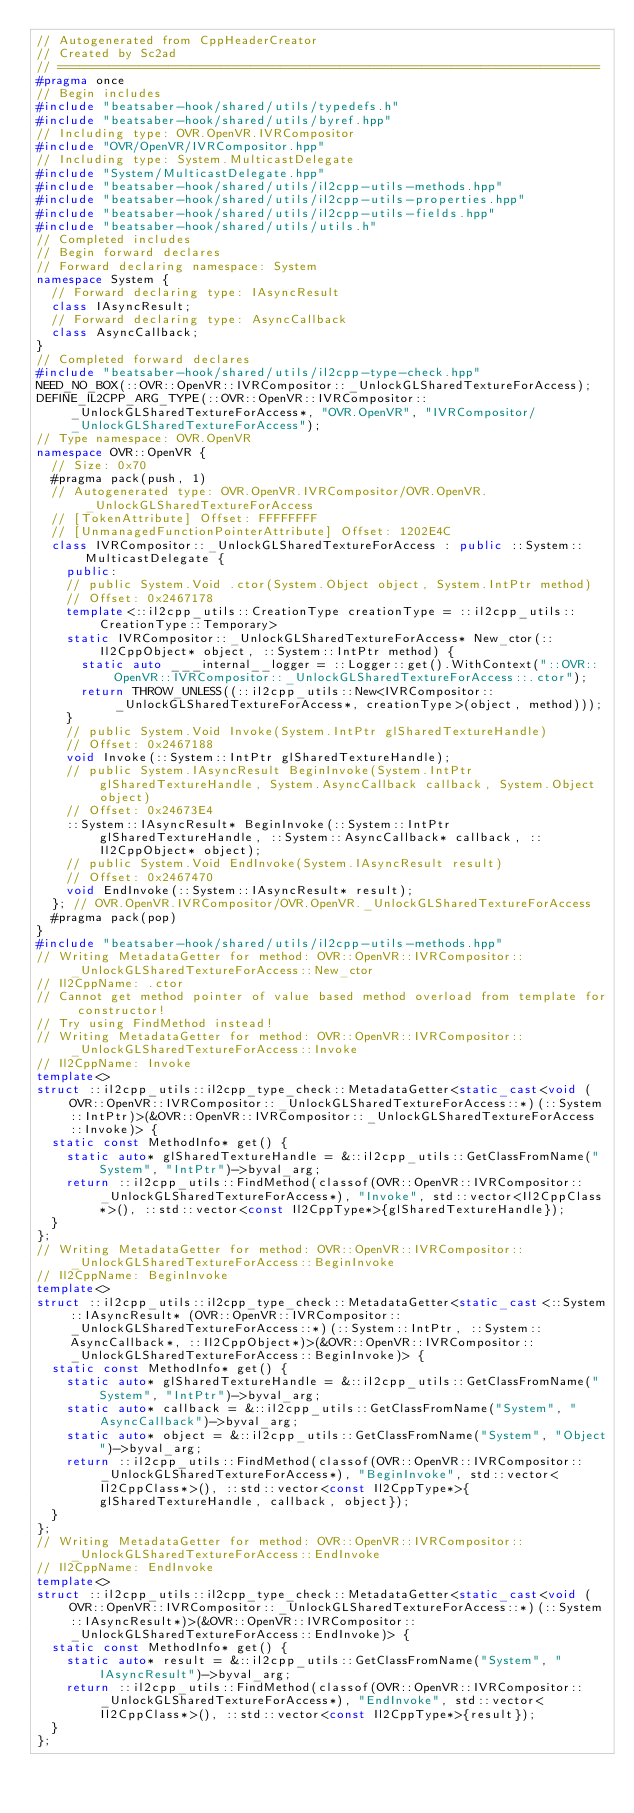<code> <loc_0><loc_0><loc_500><loc_500><_C++_>// Autogenerated from CppHeaderCreator
// Created by Sc2ad
// =========================================================================
#pragma once
// Begin includes
#include "beatsaber-hook/shared/utils/typedefs.h"
#include "beatsaber-hook/shared/utils/byref.hpp"
// Including type: OVR.OpenVR.IVRCompositor
#include "OVR/OpenVR/IVRCompositor.hpp"
// Including type: System.MulticastDelegate
#include "System/MulticastDelegate.hpp"
#include "beatsaber-hook/shared/utils/il2cpp-utils-methods.hpp"
#include "beatsaber-hook/shared/utils/il2cpp-utils-properties.hpp"
#include "beatsaber-hook/shared/utils/il2cpp-utils-fields.hpp"
#include "beatsaber-hook/shared/utils/utils.h"
// Completed includes
// Begin forward declares
// Forward declaring namespace: System
namespace System {
  // Forward declaring type: IAsyncResult
  class IAsyncResult;
  // Forward declaring type: AsyncCallback
  class AsyncCallback;
}
// Completed forward declares
#include "beatsaber-hook/shared/utils/il2cpp-type-check.hpp"
NEED_NO_BOX(::OVR::OpenVR::IVRCompositor::_UnlockGLSharedTextureForAccess);
DEFINE_IL2CPP_ARG_TYPE(::OVR::OpenVR::IVRCompositor::_UnlockGLSharedTextureForAccess*, "OVR.OpenVR", "IVRCompositor/_UnlockGLSharedTextureForAccess");
// Type namespace: OVR.OpenVR
namespace OVR::OpenVR {
  // Size: 0x70
  #pragma pack(push, 1)
  // Autogenerated type: OVR.OpenVR.IVRCompositor/OVR.OpenVR._UnlockGLSharedTextureForAccess
  // [TokenAttribute] Offset: FFFFFFFF
  // [UnmanagedFunctionPointerAttribute] Offset: 1202E4C
  class IVRCompositor::_UnlockGLSharedTextureForAccess : public ::System::MulticastDelegate {
    public:
    // public System.Void .ctor(System.Object object, System.IntPtr method)
    // Offset: 0x2467178
    template<::il2cpp_utils::CreationType creationType = ::il2cpp_utils::CreationType::Temporary>
    static IVRCompositor::_UnlockGLSharedTextureForAccess* New_ctor(::Il2CppObject* object, ::System::IntPtr method) {
      static auto ___internal__logger = ::Logger::get().WithContext("::OVR::OpenVR::IVRCompositor::_UnlockGLSharedTextureForAccess::.ctor");
      return THROW_UNLESS((::il2cpp_utils::New<IVRCompositor::_UnlockGLSharedTextureForAccess*, creationType>(object, method)));
    }
    // public System.Void Invoke(System.IntPtr glSharedTextureHandle)
    // Offset: 0x2467188
    void Invoke(::System::IntPtr glSharedTextureHandle);
    // public System.IAsyncResult BeginInvoke(System.IntPtr glSharedTextureHandle, System.AsyncCallback callback, System.Object object)
    // Offset: 0x24673E4
    ::System::IAsyncResult* BeginInvoke(::System::IntPtr glSharedTextureHandle, ::System::AsyncCallback* callback, ::Il2CppObject* object);
    // public System.Void EndInvoke(System.IAsyncResult result)
    // Offset: 0x2467470
    void EndInvoke(::System::IAsyncResult* result);
  }; // OVR.OpenVR.IVRCompositor/OVR.OpenVR._UnlockGLSharedTextureForAccess
  #pragma pack(pop)
}
#include "beatsaber-hook/shared/utils/il2cpp-utils-methods.hpp"
// Writing MetadataGetter for method: OVR::OpenVR::IVRCompositor::_UnlockGLSharedTextureForAccess::New_ctor
// Il2CppName: .ctor
// Cannot get method pointer of value based method overload from template for constructor!
// Try using FindMethod instead!
// Writing MetadataGetter for method: OVR::OpenVR::IVRCompositor::_UnlockGLSharedTextureForAccess::Invoke
// Il2CppName: Invoke
template<>
struct ::il2cpp_utils::il2cpp_type_check::MetadataGetter<static_cast<void (OVR::OpenVR::IVRCompositor::_UnlockGLSharedTextureForAccess::*)(::System::IntPtr)>(&OVR::OpenVR::IVRCompositor::_UnlockGLSharedTextureForAccess::Invoke)> {
  static const MethodInfo* get() {
    static auto* glSharedTextureHandle = &::il2cpp_utils::GetClassFromName("System", "IntPtr")->byval_arg;
    return ::il2cpp_utils::FindMethod(classof(OVR::OpenVR::IVRCompositor::_UnlockGLSharedTextureForAccess*), "Invoke", std::vector<Il2CppClass*>(), ::std::vector<const Il2CppType*>{glSharedTextureHandle});
  }
};
// Writing MetadataGetter for method: OVR::OpenVR::IVRCompositor::_UnlockGLSharedTextureForAccess::BeginInvoke
// Il2CppName: BeginInvoke
template<>
struct ::il2cpp_utils::il2cpp_type_check::MetadataGetter<static_cast<::System::IAsyncResult* (OVR::OpenVR::IVRCompositor::_UnlockGLSharedTextureForAccess::*)(::System::IntPtr, ::System::AsyncCallback*, ::Il2CppObject*)>(&OVR::OpenVR::IVRCompositor::_UnlockGLSharedTextureForAccess::BeginInvoke)> {
  static const MethodInfo* get() {
    static auto* glSharedTextureHandle = &::il2cpp_utils::GetClassFromName("System", "IntPtr")->byval_arg;
    static auto* callback = &::il2cpp_utils::GetClassFromName("System", "AsyncCallback")->byval_arg;
    static auto* object = &::il2cpp_utils::GetClassFromName("System", "Object")->byval_arg;
    return ::il2cpp_utils::FindMethod(classof(OVR::OpenVR::IVRCompositor::_UnlockGLSharedTextureForAccess*), "BeginInvoke", std::vector<Il2CppClass*>(), ::std::vector<const Il2CppType*>{glSharedTextureHandle, callback, object});
  }
};
// Writing MetadataGetter for method: OVR::OpenVR::IVRCompositor::_UnlockGLSharedTextureForAccess::EndInvoke
// Il2CppName: EndInvoke
template<>
struct ::il2cpp_utils::il2cpp_type_check::MetadataGetter<static_cast<void (OVR::OpenVR::IVRCompositor::_UnlockGLSharedTextureForAccess::*)(::System::IAsyncResult*)>(&OVR::OpenVR::IVRCompositor::_UnlockGLSharedTextureForAccess::EndInvoke)> {
  static const MethodInfo* get() {
    static auto* result = &::il2cpp_utils::GetClassFromName("System", "IAsyncResult")->byval_arg;
    return ::il2cpp_utils::FindMethod(classof(OVR::OpenVR::IVRCompositor::_UnlockGLSharedTextureForAccess*), "EndInvoke", std::vector<Il2CppClass*>(), ::std::vector<const Il2CppType*>{result});
  }
};
</code> 